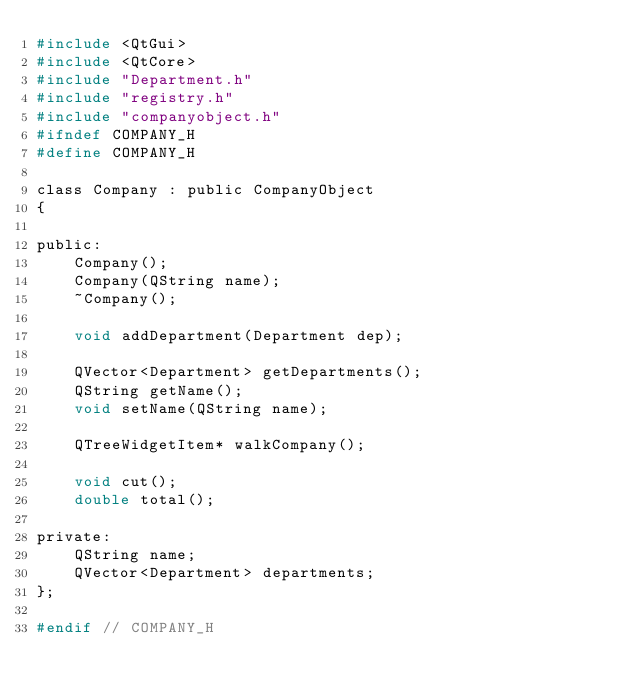<code> <loc_0><loc_0><loc_500><loc_500><_C_>#include <QtGui>
#include <QtCore>
#include "Department.h"
#include "registry.h"
#include "companyobject.h"
#ifndef COMPANY_H
#define COMPANY_H

class Company : public CompanyObject
{

public:
    Company();
    Company(QString name);
    ~Company();

    void addDepartment(Department dep);

    QVector<Department> getDepartments();
    QString getName();
    void setName(QString name);

    QTreeWidgetItem* walkCompany();

    void cut();
    double total();

private:
    QString name;
    QVector<Department> departments;
};

#endif // COMPANY_H


</code> 